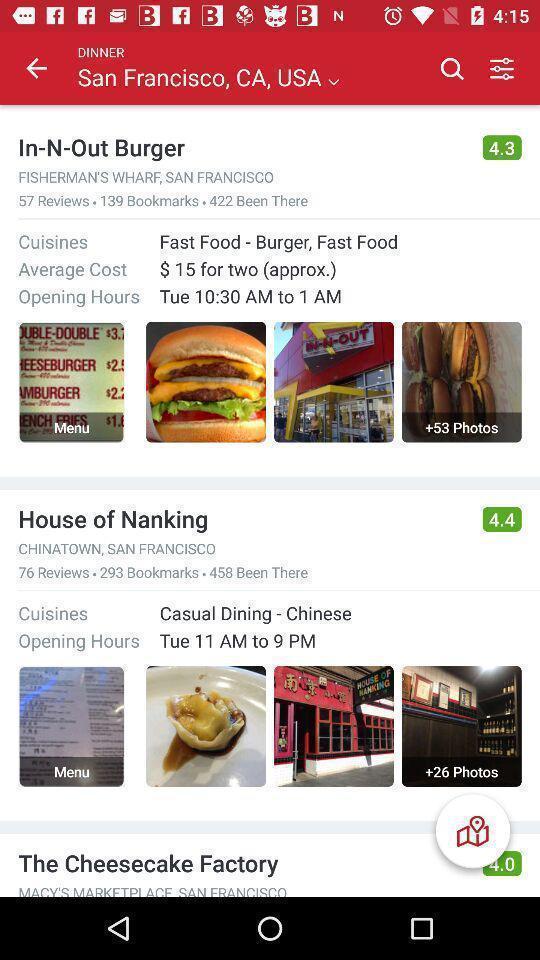Describe the key features of this screenshot. Screen shows online food store. 